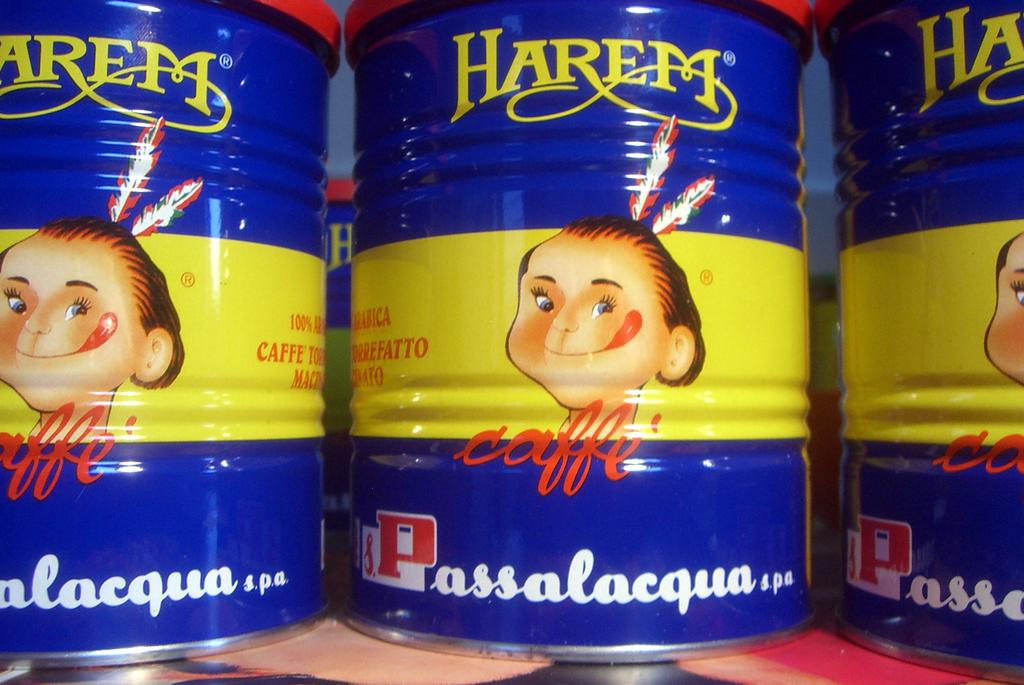<image>
Provide a brief description of the given image. A blue and yellow container with a cartoon character and the text Harem caffe 